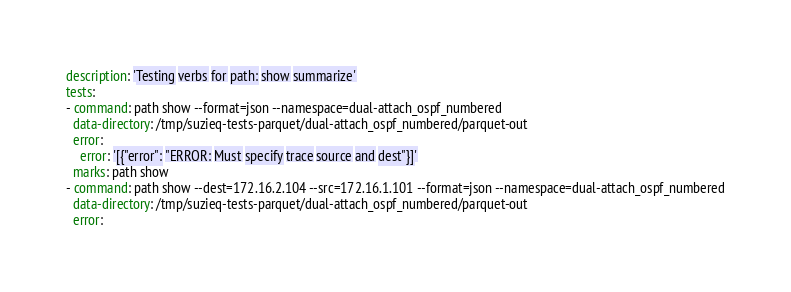<code> <loc_0><loc_0><loc_500><loc_500><_YAML_>description: 'Testing verbs for path: show summarize'
tests:
- command: path show --format=json --namespace=dual-attach_ospf_numbered
  data-directory: /tmp/suzieq-tests-parquet/dual-attach_ospf_numbered/parquet-out
  error:
    error: '[{"error": "ERROR: Must specify trace source and dest"}]'
  marks: path show
- command: path show --dest=172.16.2.104 --src=172.16.1.101 --format=json --namespace=dual-attach_ospf_numbered
  data-directory: /tmp/suzieq-tests-parquet/dual-attach_ospf_numbered/parquet-out
  error:</code> 